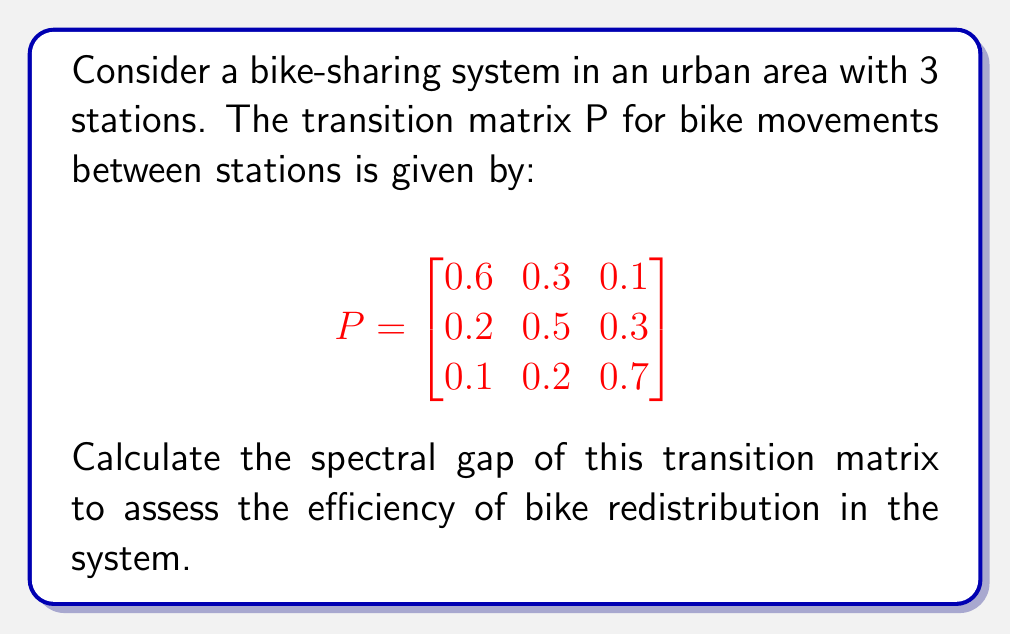Solve this math problem. To calculate the spectral gap of the transition matrix P, we follow these steps:

1. Find the eigenvalues of P:
   Solve the characteristic equation $\det(P - \lambda I) = 0$
   
   $$\det\begin{pmatrix}
   0.6-\lambda & 0.3 & 0.1 \\
   0.2 & 0.5-\lambda & 0.3 \\
   0.1 & 0.2 & 0.7-\lambda
   \end{pmatrix} = 0$$
   
   This yields the equation:
   $-\lambda^3 + 1.8\lambda^2 - 0.97\lambda + 0.17 = 0$

2. Solve this equation to find the eigenvalues:
   $\lambda_1 = 1$ (always an eigenvalue for stochastic matrices)
   $\lambda_2 \approx 0.5697$
   $\lambda_3 \approx 0.2303$

3. Order the eigenvalues by magnitude:
   $|\lambda_1| > |\lambda_2| > |\lambda_3|$

4. The spectral gap is defined as the difference between the largest and second-largest eigenvalues in absolute value:
   Spectral gap $= |\lambda_1| - |\lambda_2| = 1 - 0.5697 \approx 0.4303$

This spectral gap indicates how quickly the bike-sharing system approaches its equilibrium distribution. A larger gap suggests faster convergence to the steady-state, implying more efficient bike redistribution across stations.
Answer: 0.4303 